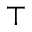Convert formula to latex. <formula><loc_0><loc_0><loc_500><loc_500>\top</formula> 